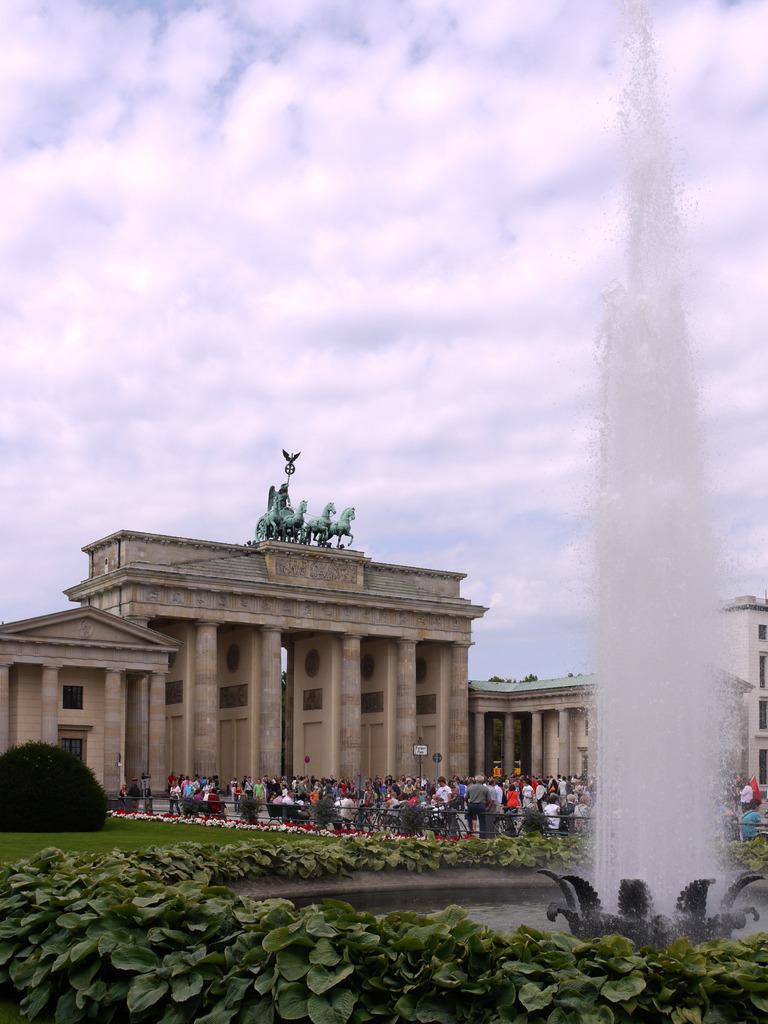Please provide a concise description of this image. In this image I see the plants over here and I see the fountain. In the background I see number of people and I see the grass and I see the bushes over here and I see the buildings and I see the statue over here and I see the sky. 